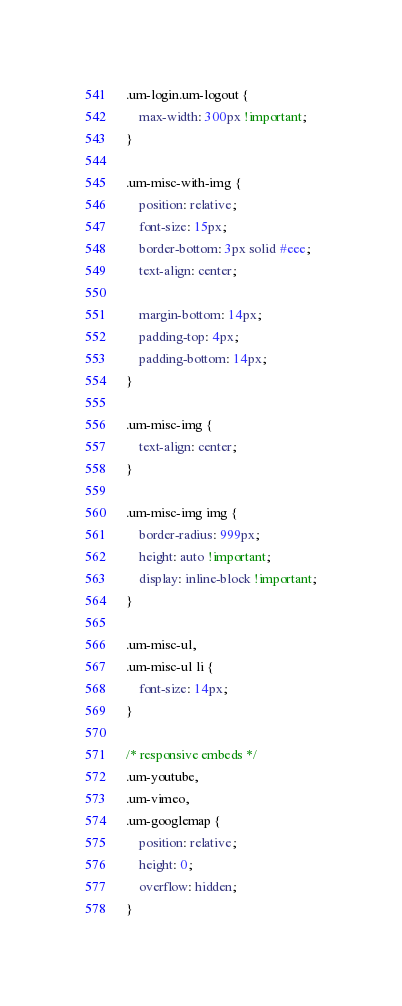<code> <loc_0><loc_0><loc_500><loc_500><_CSS_>.um-login.um-logout {
	max-width: 300px !important;
}

.um-misc-with-img {
	position: relative;
	font-size: 15px;
	border-bottom: 3px solid #eee;
	text-align: center;
	
	margin-bottom: 14px;
	padding-top: 4px;
	padding-bottom: 14px;
}

.um-misc-img {
	text-align: center;
}

.um-misc-img img {
	border-radius: 999px;
	height: auto !important;
	display: inline-block !important;
}

.um-misc-ul,
.um-misc-ul li {
	font-size: 14px;
}

/* responsive embeds */
.um-youtube,
.um-vimeo,
.um-googlemap {
	position: relative;
	height: 0;
	overflow: hidden;
}
</code> 